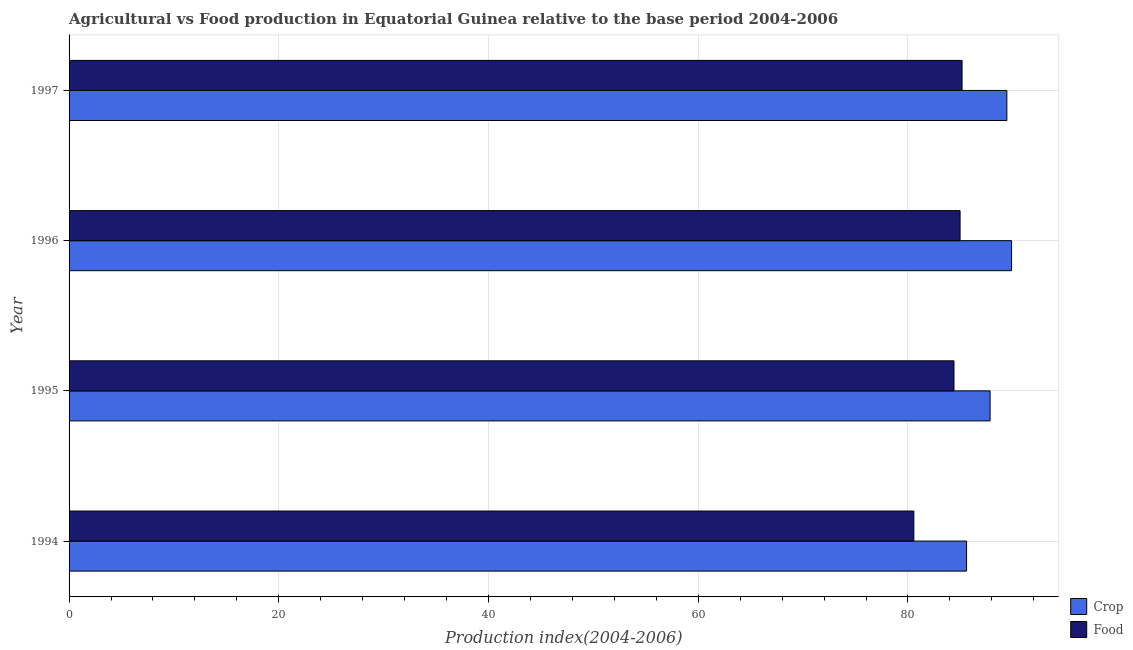How many groups of bars are there?
Give a very brief answer. 4. Are the number of bars per tick equal to the number of legend labels?
Ensure brevity in your answer.  Yes. How many bars are there on the 4th tick from the top?
Ensure brevity in your answer.  2. How many bars are there on the 2nd tick from the bottom?
Offer a very short reply. 2. What is the label of the 2nd group of bars from the top?
Offer a terse response. 1996. In how many cases, is the number of bars for a given year not equal to the number of legend labels?
Provide a short and direct response. 0. What is the crop production index in 1996?
Offer a terse response. 89.88. Across all years, what is the maximum crop production index?
Offer a very short reply. 89.88. Across all years, what is the minimum food production index?
Your answer should be very brief. 80.56. In which year was the crop production index minimum?
Your answer should be compact. 1994. What is the total crop production index in the graph?
Your answer should be compact. 352.73. What is the difference between the crop production index in 1995 and that in 1996?
Offer a terse response. -2.05. What is the difference between the crop production index in 1996 and the food production index in 1994?
Provide a short and direct response. 9.32. What is the average crop production index per year?
Your response must be concise. 88.18. In the year 1995, what is the difference between the food production index and crop production index?
Ensure brevity in your answer.  -3.44. Is the food production index in 1994 less than that in 1997?
Provide a short and direct response. Yes. Is the difference between the crop production index in 1994 and 1995 greater than the difference between the food production index in 1994 and 1995?
Make the answer very short. Yes. What is the difference between the highest and the second highest crop production index?
Offer a very short reply. 0.45. What is the difference between the highest and the lowest food production index?
Provide a short and direct response. 4.6. In how many years, is the food production index greater than the average food production index taken over all years?
Give a very brief answer. 3. What does the 2nd bar from the top in 1997 represents?
Your answer should be compact. Crop. What does the 1st bar from the bottom in 1996 represents?
Your answer should be very brief. Crop. How many bars are there?
Provide a succinct answer. 8. Does the graph contain any zero values?
Your answer should be compact. No. How many legend labels are there?
Give a very brief answer. 2. What is the title of the graph?
Make the answer very short. Agricultural vs Food production in Equatorial Guinea relative to the base period 2004-2006. Does "Electricity" appear as one of the legend labels in the graph?
Your answer should be compact. No. What is the label or title of the X-axis?
Ensure brevity in your answer.  Production index(2004-2006). What is the label or title of the Y-axis?
Your answer should be very brief. Year. What is the Production index(2004-2006) in Crop in 1994?
Provide a succinct answer. 85.59. What is the Production index(2004-2006) in Food in 1994?
Ensure brevity in your answer.  80.56. What is the Production index(2004-2006) of Crop in 1995?
Offer a terse response. 87.83. What is the Production index(2004-2006) of Food in 1995?
Make the answer very short. 84.39. What is the Production index(2004-2006) of Crop in 1996?
Offer a very short reply. 89.88. What is the Production index(2004-2006) of Food in 1996?
Provide a succinct answer. 84.97. What is the Production index(2004-2006) of Crop in 1997?
Your answer should be compact. 89.43. What is the Production index(2004-2006) of Food in 1997?
Your response must be concise. 85.16. Across all years, what is the maximum Production index(2004-2006) in Crop?
Your answer should be very brief. 89.88. Across all years, what is the maximum Production index(2004-2006) of Food?
Give a very brief answer. 85.16. Across all years, what is the minimum Production index(2004-2006) in Crop?
Make the answer very short. 85.59. Across all years, what is the minimum Production index(2004-2006) of Food?
Provide a succinct answer. 80.56. What is the total Production index(2004-2006) in Crop in the graph?
Provide a succinct answer. 352.73. What is the total Production index(2004-2006) in Food in the graph?
Ensure brevity in your answer.  335.08. What is the difference between the Production index(2004-2006) of Crop in 1994 and that in 1995?
Offer a terse response. -2.24. What is the difference between the Production index(2004-2006) in Food in 1994 and that in 1995?
Make the answer very short. -3.83. What is the difference between the Production index(2004-2006) of Crop in 1994 and that in 1996?
Keep it short and to the point. -4.29. What is the difference between the Production index(2004-2006) of Food in 1994 and that in 1996?
Give a very brief answer. -4.41. What is the difference between the Production index(2004-2006) of Crop in 1994 and that in 1997?
Keep it short and to the point. -3.84. What is the difference between the Production index(2004-2006) in Food in 1994 and that in 1997?
Keep it short and to the point. -4.6. What is the difference between the Production index(2004-2006) of Crop in 1995 and that in 1996?
Offer a terse response. -2.05. What is the difference between the Production index(2004-2006) in Food in 1995 and that in 1996?
Your answer should be very brief. -0.58. What is the difference between the Production index(2004-2006) in Crop in 1995 and that in 1997?
Your answer should be very brief. -1.6. What is the difference between the Production index(2004-2006) of Food in 1995 and that in 1997?
Provide a succinct answer. -0.77. What is the difference between the Production index(2004-2006) of Crop in 1996 and that in 1997?
Your response must be concise. 0.45. What is the difference between the Production index(2004-2006) of Food in 1996 and that in 1997?
Your answer should be very brief. -0.19. What is the difference between the Production index(2004-2006) in Crop in 1994 and the Production index(2004-2006) in Food in 1996?
Ensure brevity in your answer.  0.62. What is the difference between the Production index(2004-2006) of Crop in 1994 and the Production index(2004-2006) of Food in 1997?
Your response must be concise. 0.43. What is the difference between the Production index(2004-2006) in Crop in 1995 and the Production index(2004-2006) in Food in 1996?
Make the answer very short. 2.86. What is the difference between the Production index(2004-2006) in Crop in 1995 and the Production index(2004-2006) in Food in 1997?
Keep it short and to the point. 2.67. What is the difference between the Production index(2004-2006) in Crop in 1996 and the Production index(2004-2006) in Food in 1997?
Give a very brief answer. 4.72. What is the average Production index(2004-2006) of Crop per year?
Keep it short and to the point. 88.18. What is the average Production index(2004-2006) in Food per year?
Provide a succinct answer. 83.77. In the year 1994, what is the difference between the Production index(2004-2006) of Crop and Production index(2004-2006) of Food?
Your answer should be compact. 5.03. In the year 1995, what is the difference between the Production index(2004-2006) of Crop and Production index(2004-2006) of Food?
Your response must be concise. 3.44. In the year 1996, what is the difference between the Production index(2004-2006) in Crop and Production index(2004-2006) in Food?
Your answer should be very brief. 4.91. In the year 1997, what is the difference between the Production index(2004-2006) of Crop and Production index(2004-2006) of Food?
Give a very brief answer. 4.27. What is the ratio of the Production index(2004-2006) of Crop in 1994 to that in 1995?
Your answer should be compact. 0.97. What is the ratio of the Production index(2004-2006) of Food in 1994 to that in 1995?
Offer a terse response. 0.95. What is the ratio of the Production index(2004-2006) in Crop in 1994 to that in 1996?
Make the answer very short. 0.95. What is the ratio of the Production index(2004-2006) in Food in 1994 to that in 1996?
Keep it short and to the point. 0.95. What is the ratio of the Production index(2004-2006) of Crop in 1994 to that in 1997?
Offer a very short reply. 0.96. What is the ratio of the Production index(2004-2006) in Food in 1994 to that in 1997?
Give a very brief answer. 0.95. What is the ratio of the Production index(2004-2006) of Crop in 1995 to that in 1996?
Provide a succinct answer. 0.98. What is the ratio of the Production index(2004-2006) in Food in 1995 to that in 1996?
Your answer should be compact. 0.99. What is the ratio of the Production index(2004-2006) in Crop in 1995 to that in 1997?
Offer a very short reply. 0.98. What is the ratio of the Production index(2004-2006) in Food in 1995 to that in 1997?
Keep it short and to the point. 0.99. What is the ratio of the Production index(2004-2006) of Food in 1996 to that in 1997?
Your answer should be very brief. 1. What is the difference between the highest and the second highest Production index(2004-2006) of Crop?
Your response must be concise. 0.45. What is the difference between the highest and the second highest Production index(2004-2006) of Food?
Ensure brevity in your answer.  0.19. What is the difference between the highest and the lowest Production index(2004-2006) in Crop?
Keep it short and to the point. 4.29. 